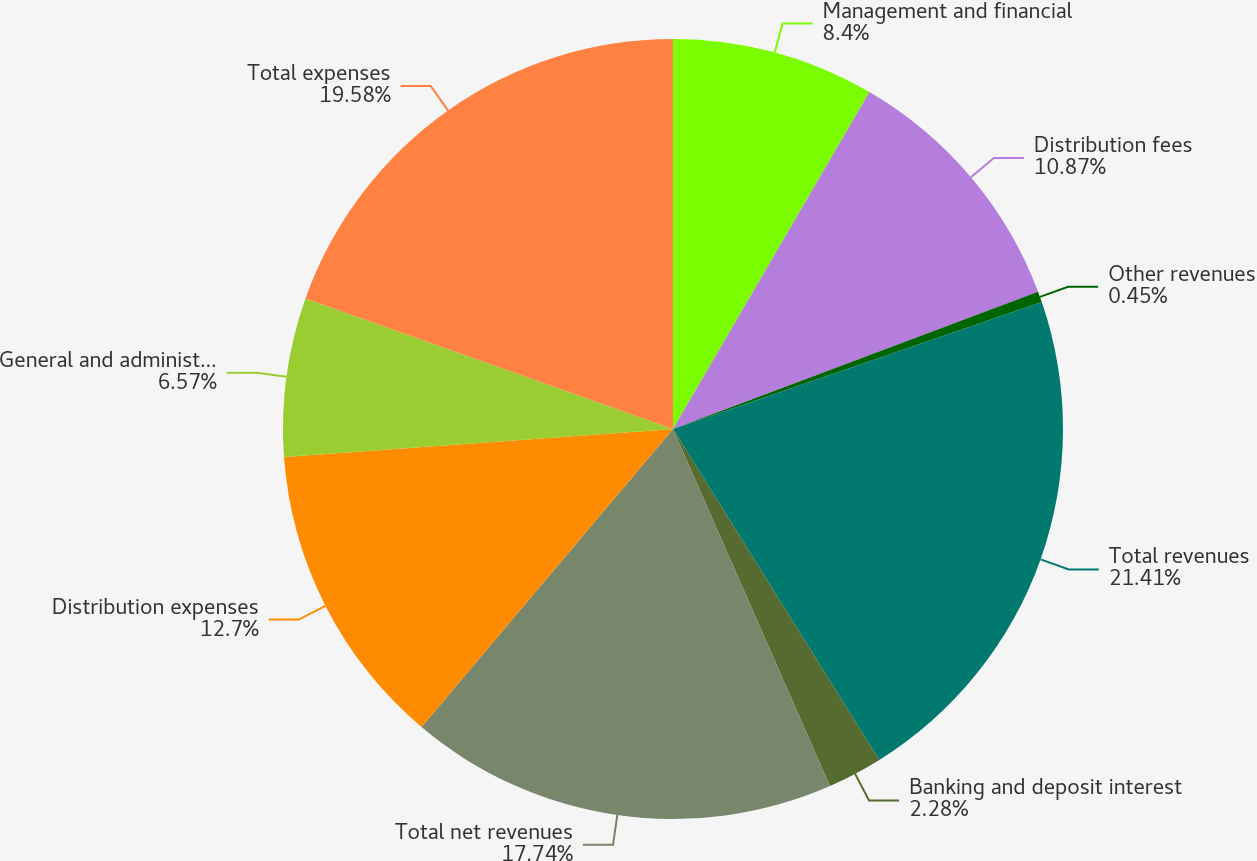Convert chart. <chart><loc_0><loc_0><loc_500><loc_500><pie_chart><fcel>Management and financial<fcel>Distribution fees<fcel>Other revenues<fcel>Total revenues<fcel>Banking and deposit interest<fcel>Total net revenues<fcel>Distribution expenses<fcel>General and administrative<fcel>Total expenses<nl><fcel>8.4%<fcel>10.87%<fcel>0.45%<fcel>21.4%<fcel>2.28%<fcel>17.74%<fcel>12.7%<fcel>6.57%<fcel>19.57%<nl></chart> 